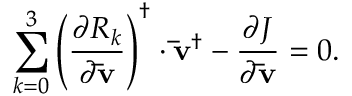Convert formula to latex. <formula><loc_0><loc_0><loc_500><loc_500>\sum _ { k = 0 } ^ { 3 } { { { \left ( { \frac { { \partial { R _ { k } } } } { { \partial { \bar { v } } } } } \right ) } ^ { \dag } } \cdot { { { \bar { v } } } ^ { \dag } } } - \frac { \partial J } { { \partial { \bar { v } } } } = 0 .</formula> 